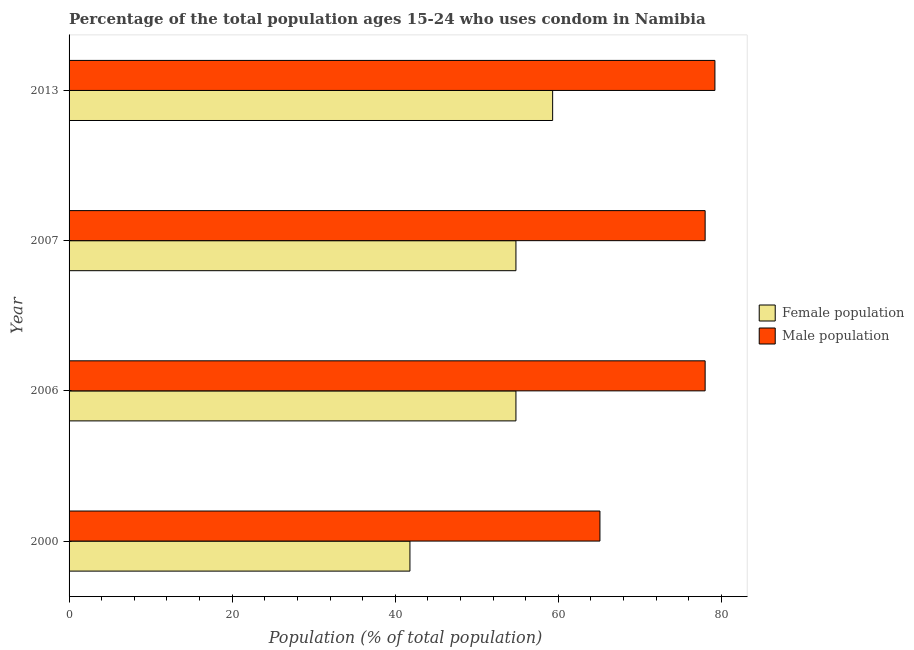How many groups of bars are there?
Ensure brevity in your answer.  4. Are the number of bars on each tick of the Y-axis equal?
Make the answer very short. Yes. How many bars are there on the 2nd tick from the bottom?
Your answer should be very brief. 2. What is the label of the 2nd group of bars from the top?
Your answer should be very brief. 2007. In how many cases, is the number of bars for a given year not equal to the number of legend labels?
Offer a terse response. 0. What is the female population in 2006?
Keep it short and to the point. 54.8. Across all years, what is the maximum female population?
Provide a succinct answer. 59.3. Across all years, what is the minimum male population?
Your answer should be compact. 65.1. In which year was the male population maximum?
Provide a succinct answer. 2013. What is the total male population in the graph?
Your answer should be compact. 300.3. What is the difference between the female population in 2006 and the male population in 2013?
Offer a terse response. -24.4. What is the average male population per year?
Keep it short and to the point. 75.08. In the year 2006, what is the difference between the female population and male population?
Give a very brief answer. -23.2. In how many years, is the female population greater than 56 %?
Make the answer very short. 1. What is the ratio of the male population in 2006 to that in 2013?
Offer a very short reply. 0.98. Is the female population in 2007 less than that in 2013?
Your response must be concise. Yes. In how many years, is the male population greater than the average male population taken over all years?
Make the answer very short. 3. Is the sum of the female population in 2000 and 2013 greater than the maximum male population across all years?
Your response must be concise. Yes. What does the 2nd bar from the top in 2006 represents?
Your response must be concise. Female population. What does the 1st bar from the bottom in 2000 represents?
Ensure brevity in your answer.  Female population. Are all the bars in the graph horizontal?
Keep it short and to the point. Yes. What is the difference between two consecutive major ticks on the X-axis?
Your answer should be very brief. 20. Does the graph contain any zero values?
Give a very brief answer. No. Where does the legend appear in the graph?
Ensure brevity in your answer.  Center right. What is the title of the graph?
Offer a terse response. Percentage of the total population ages 15-24 who uses condom in Namibia. What is the label or title of the X-axis?
Provide a succinct answer. Population (% of total population) . What is the Population (% of total population)  in Female population in 2000?
Keep it short and to the point. 41.8. What is the Population (% of total population)  in Male population in 2000?
Provide a short and direct response. 65.1. What is the Population (% of total population)  in Female population in 2006?
Your response must be concise. 54.8. What is the Population (% of total population)  of Male population in 2006?
Offer a very short reply. 78. What is the Population (% of total population)  of Female population in 2007?
Make the answer very short. 54.8. What is the Population (% of total population)  in Female population in 2013?
Provide a succinct answer. 59.3. What is the Population (% of total population)  in Male population in 2013?
Offer a very short reply. 79.2. Across all years, what is the maximum Population (% of total population)  in Female population?
Your answer should be very brief. 59.3. Across all years, what is the maximum Population (% of total population)  in Male population?
Your answer should be compact. 79.2. Across all years, what is the minimum Population (% of total population)  in Female population?
Your answer should be very brief. 41.8. Across all years, what is the minimum Population (% of total population)  of Male population?
Provide a short and direct response. 65.1. What is the total Population (% of total population)  in Female population in the graph?
Provide a short and direct response. 210.7. What is the total Population (% of total population)  of Male population in the graph?
Offer a very short reply. 300.3. What is the difference between the Population (% of total population)  in Female population in 2000 and that in 2013?
Ensure brevity in your answer.  -17.5. What is the difference between the Population (% of total population)  of Male population in 2000 and that in 2013?
Your answer should be compact. -14.1. What is the difference between the Population (% of total population)  in Female population in 2006 and that in 2007?
Offer a terse response. 0. What is the difference between the Population (% of total population)  of Female population in 2006 and that in 2013?
Provide a short and direct response. -4.5. What is the difference between the Population (% of total population)  in Male population in 2006 and that in 2013?
Offer a very short reply. -1.2. What is the difference between the Population (% of total population)  of Female population in 2007 and that in 2013?
Keep it short and to the point. -4.5. What is the difference between the Population (% of total population)  in Male population in 2007 and that in 2013?
Your answer should be compact. -1.2. What is the difference between the Population (% of total population)  of Female population in 2000 and the Population (% of total population)  of Male population in 2006?
Your response must be concise. -36.2. What is the difference between the Population (% of total population)  of Female population in 2000 and the Population (% of total population)  of Male population in 2007?
Give a very brief answer. -36.2. What is the difference between the Population (% of total population)  in Female population in 2000 and the Population (% of total population)  in Male population in 2013?
Your answer should be very brief. -37.4. What is the difference between the Population (% of total population)  in Female population in 2006 and the Population (% of total population)  in Male population in 2007?
Your answer should be compact. -23.2. What is the difference between the Population (% of total population)  of Female population in 2006 and the Population (% of total population)  of Male population in 2013?
Keep it short and to the point. -24.4. What is the difference between the Population (% of total population)  in Female population in 2007 and the Population (% of total population)  in Male population in 2013?
Make the answer very short. -24.4. What is the average Population (% of total population)  of Female population per year?
Offer a terse response. 52.67. What is the average Population (% of total population)  of Male population per year?
Ensure brevity in your answer.  75.08. In the year 2000, what is the difference between the Population (% of total population)  in Female population and Population (% of total population)  in Male population?
Your response must be concise. -23.3. In the year 2006, what is the difference between the Population (% of total population)  in Female population and Population (% of total population)  in Male population?
Your answer should be compact. -23.2. In the year 2007, what is the difference between the Population (% of total population)  in Female population and Population (% of total population)  in Male population?
Make the answer very short. -23.2. In the year 2013, what is the difference between the Population (% of total population)  in Female population and Population (% of total population)  in Male population?
Give a very brief answer. -19.9. What is the ratio of the Population (% of total population)  of Female population in 2000 to that in 2006?
Your answer should be very brief. 0.76. What is the ratio of the Population (% of total population)  of Male population in 2000 to that in 2006?
Your response must be concise. 0.83. What is the ratio of the Population (% of total population)  of Female population in 2000 to that in 2007?
Keep it short and to the point. 0.76. What is the ratio of the Population (% of total population)  of Male population in 2000 to that in 2007?
Your answer should be compact. 0.83. What is the ratio of the Population (% of total population)  of Female population in 2000 to that in 2013?
Provide a short and direct response. 0.7. What is the ratio of the Population (% of total population)  in Male population in 2000 to that in 2013?
Offer a very short reply. 0.82. What is the ratio of the Population (% of total population)  of Male population in 2006 to that in 2007?
Offer a terse response. 1. What is the ratio of the Population (% of total population)  of Female population in 2006 to that in 2013?
Provide a succinct answer. 0.92. What is the ratio of the Population (% of total population)  of Male population in 2006 to that in 2013?
Your answer should be compact. 0.98. What is the ratio of the Population (% of total population)  in Female population in 2007 to that in 2013?
Your response must be concise. 0.92. What is the difference between the highest and the second highest Population (% of total population)  of Female population?
Give a very brief answer. 4.5. What is the difference between the highest and the second highest Population (% of total population)  of Male population?
Your response must be concise. 1.2. What is the difference between the highest and the lowest Population (% of total population)  in Female population?
Provide a succinct answer. 17.5. What is the difference between the highest and the lowest Population (% of total population)  in Male population?
Your response must be concise. 14.1. 